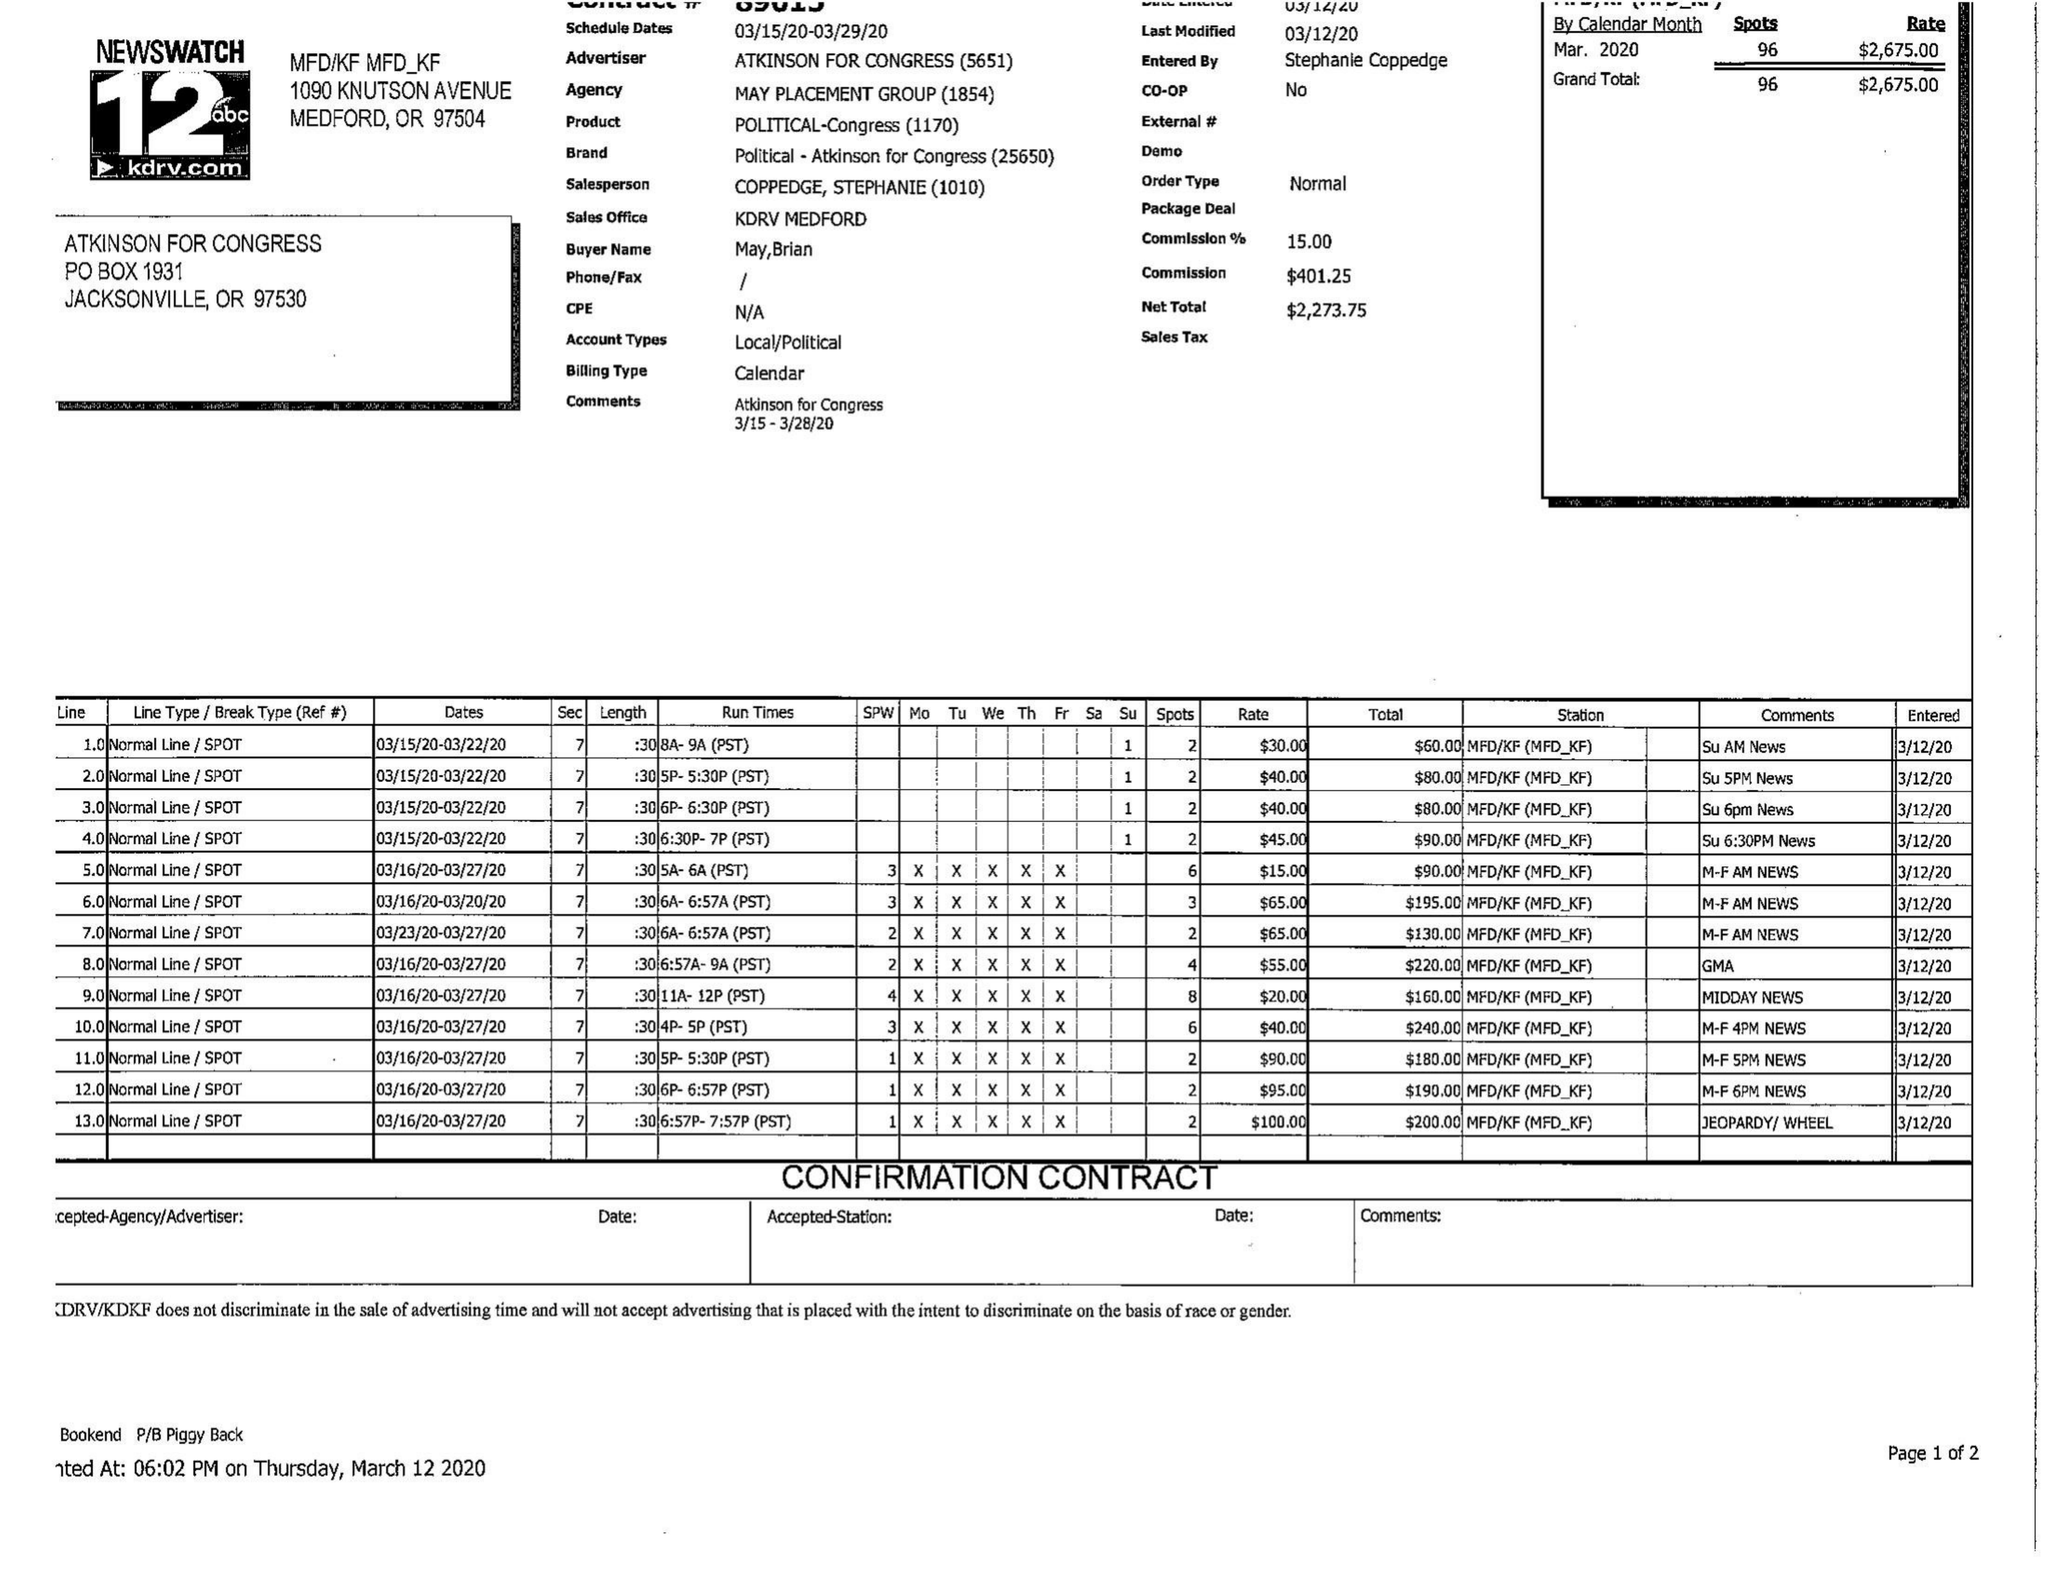What is the value for the contract_num?
Answer the question using a single word or phrase. None 